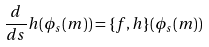Convert formula to latex. <formula><loc_0><loc_0><loc_500><loc_500>\frac { d } { d s } h ( \phi _ { s } ( m ) ) = \{ f , h \} ( \phi _ { s } ( m ) )</formula> 